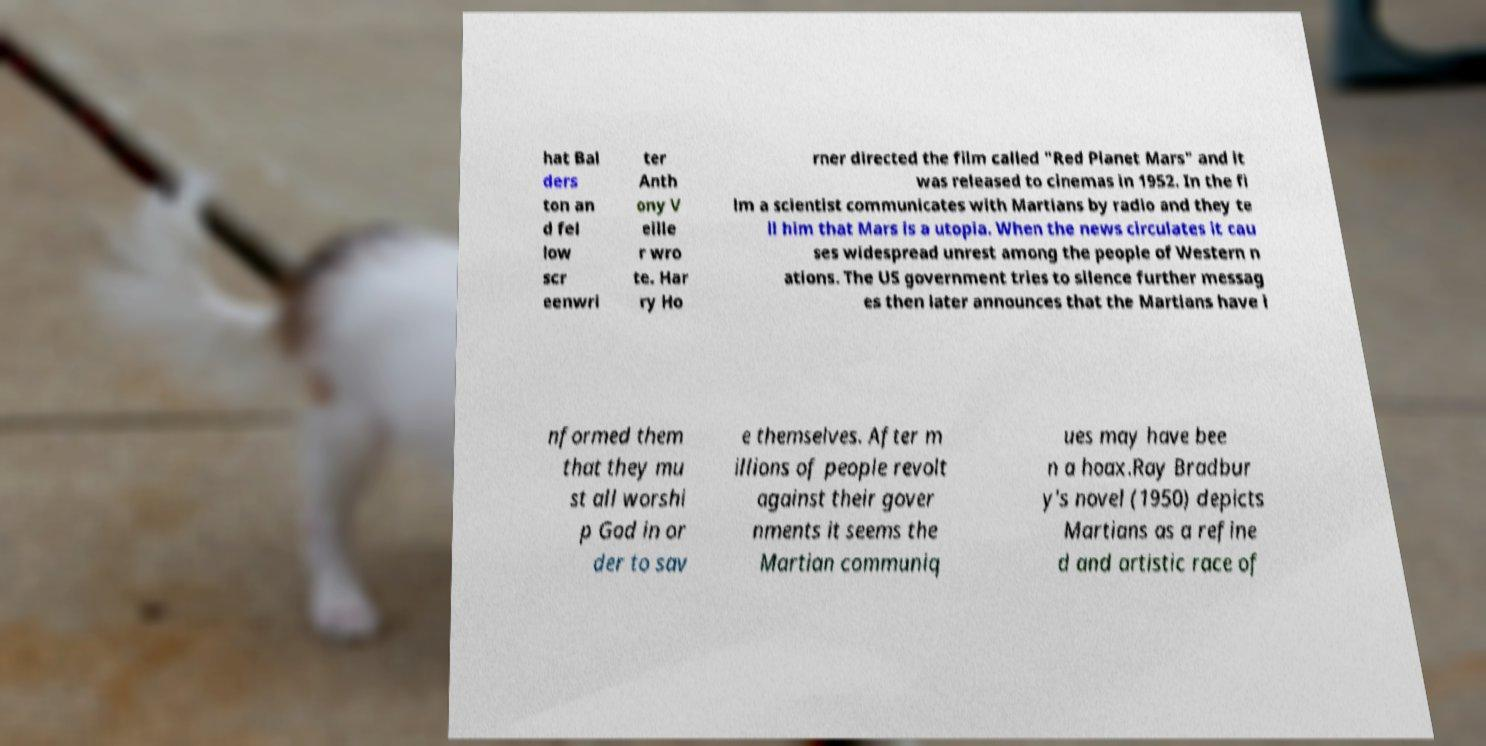There's text embedded in this image that I need extracted. Can you transcribe it verbatim? hat Bal ders ton an d fel low scr eenwri ter Anth ony V eille r wro te. Har ry Ho rner directed the film called "Red Planet Mars" and it was released to cinemas in 1952. In the fi lm a scientist communicates with Martians by radio and they te ll him that Mars is a utopia. When the news circulates it cau ses widespread unrest among the people of Western n ations. The US government tries to silence further messag es then later announces that the Martians have i nformed them that they mu st all worshi p God in or der to sav e themselves. After m illions of people revolt against their gover nments it seems the Martian communiq ues may have bee n a hoax.Ray Bradbur y's novel (1950) depicts Martians as a refine d and artistic race of 